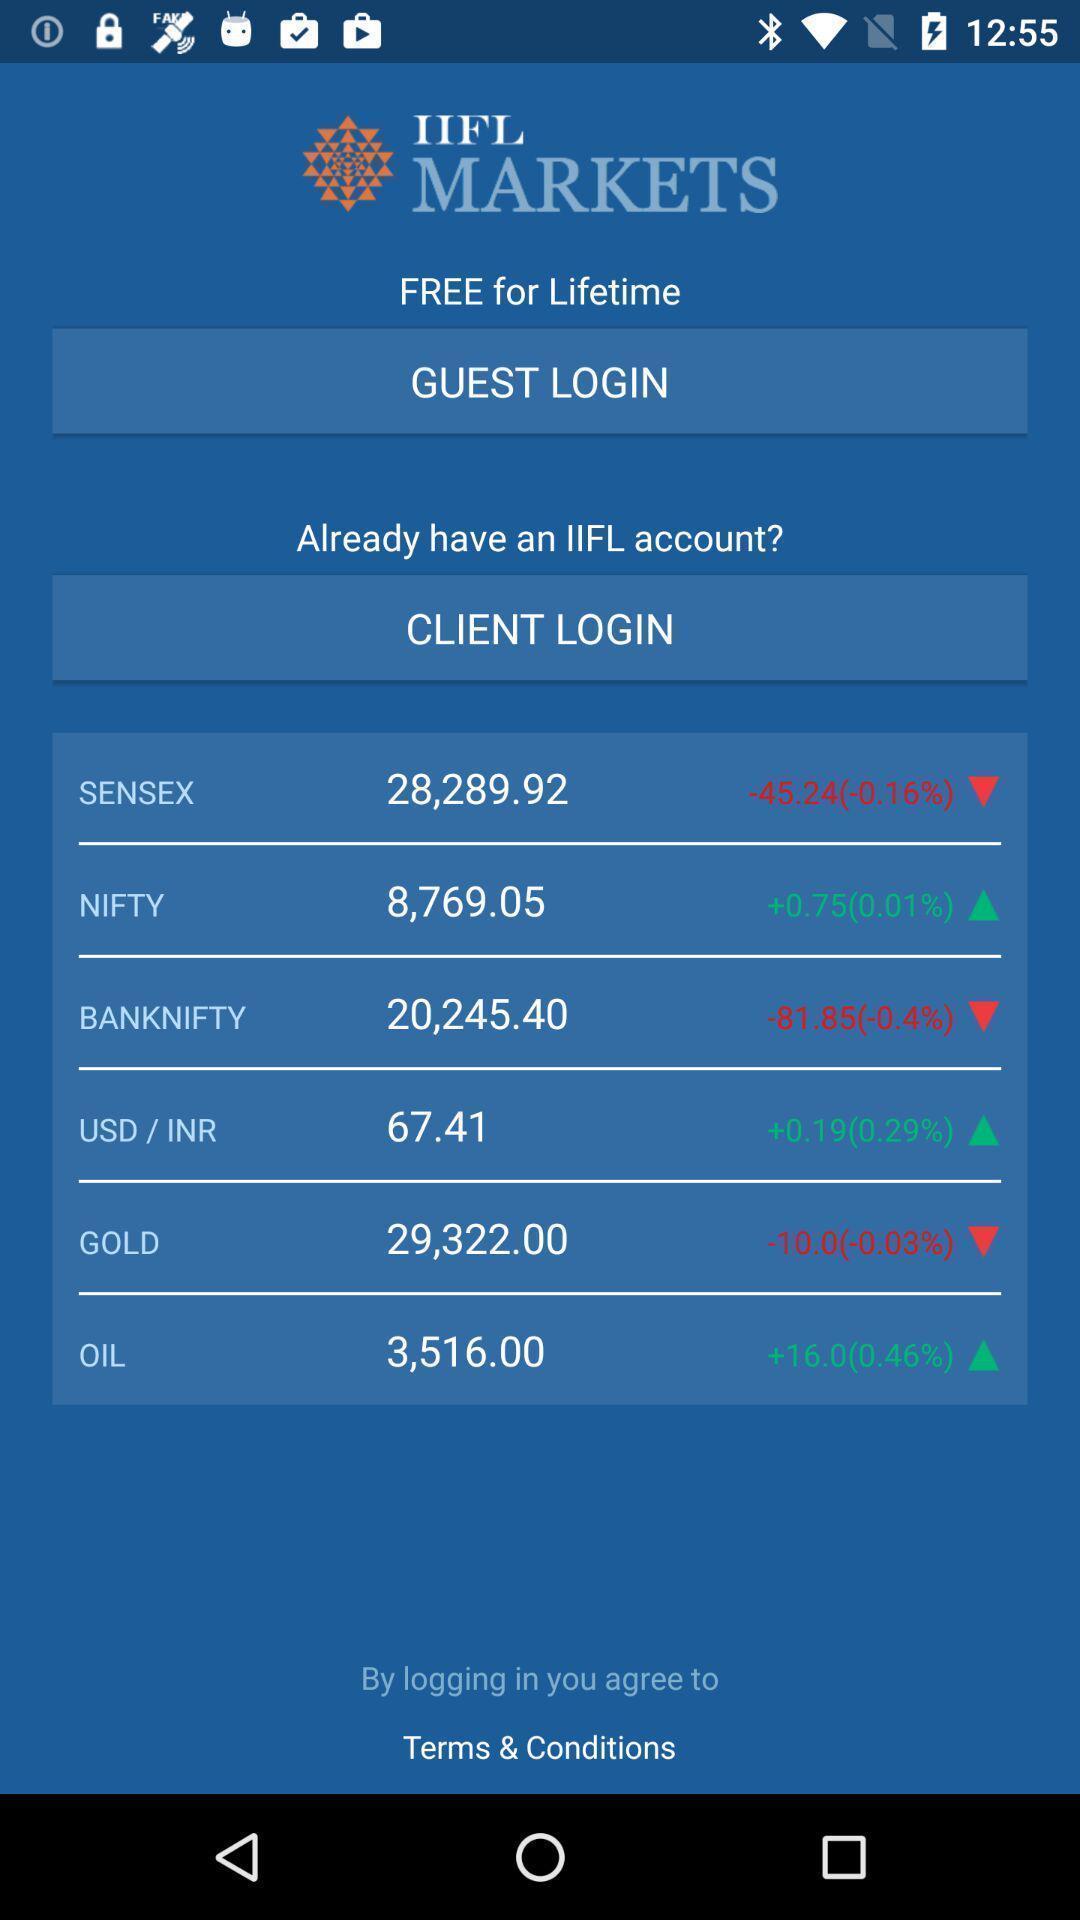Tell me about the visual elements in this screen capture. Screen shows login options in trading app. 